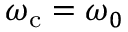<formula> <loc_0><loc_0><loc_500><loc_500>\omega _ { c } = \omega _ { 0 }</formula> 